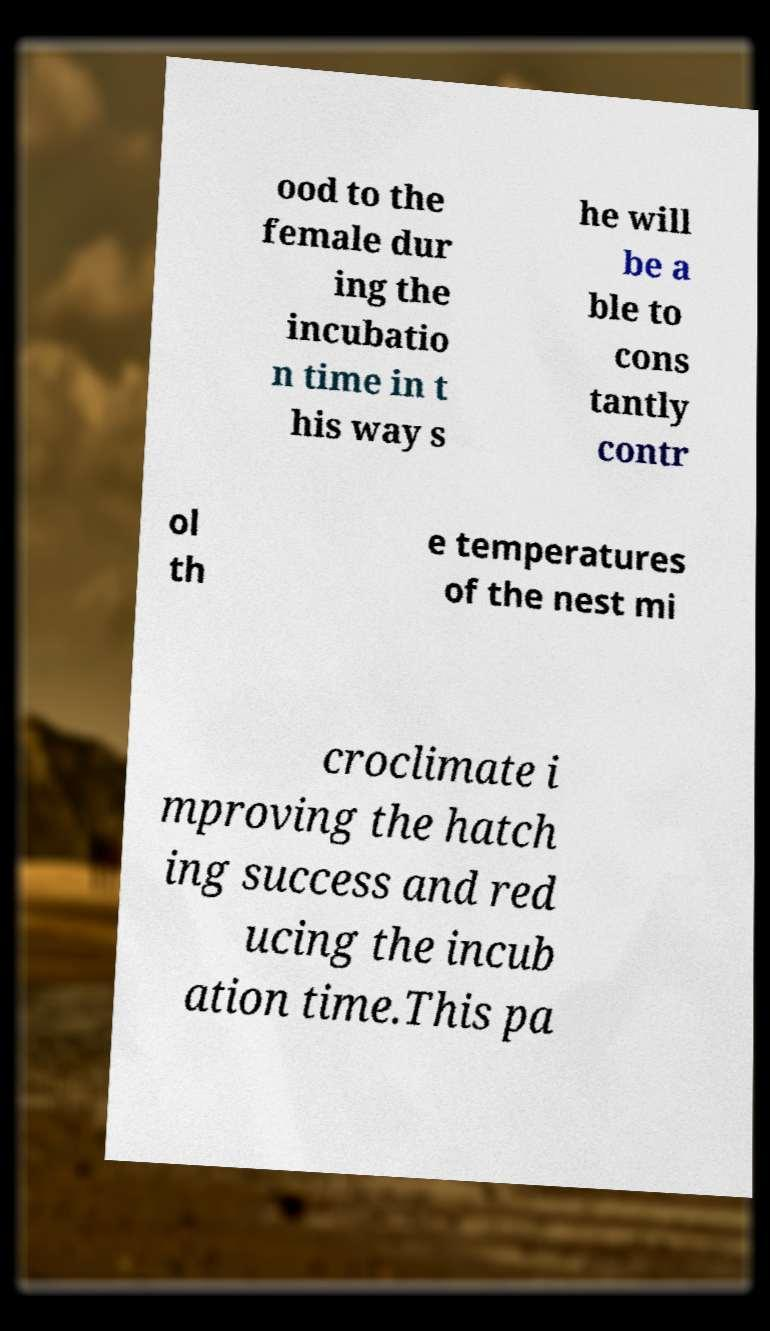I need the written content from this picture converted into text. Can you do that? ood to the female dur ing the incubatio n time in t his way s he will be a ble to cons tantly contr ol th e temperatures of the nest mi croclimate i mproving the hatch ing success and red ucing the incub ation time.This pa 